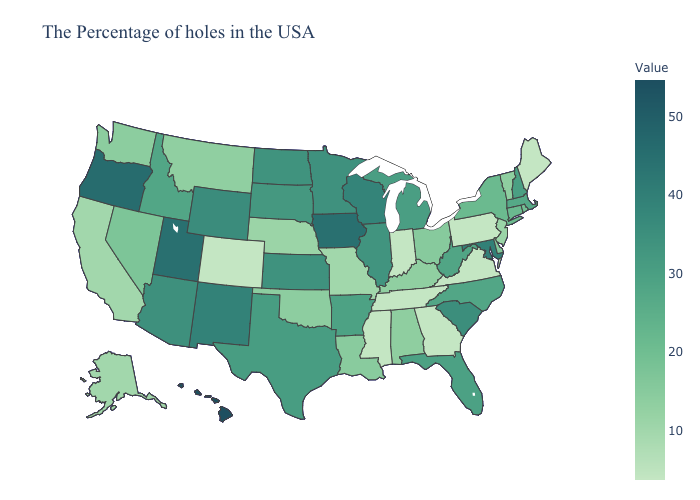Which states have the lowest value in the West?
Keep it brief. Colorado. Among the states that border New Jersey , which have the lowest value?
Short answer required. Pennsylvania. Does Alaska have the lowest value in the USA?
Short answer required. No. Does North Carolina have the lowest value in the USA?
Keep it brief. No. Which states hav the highest value in the MidWest?
Concise answer only. Iowa. 